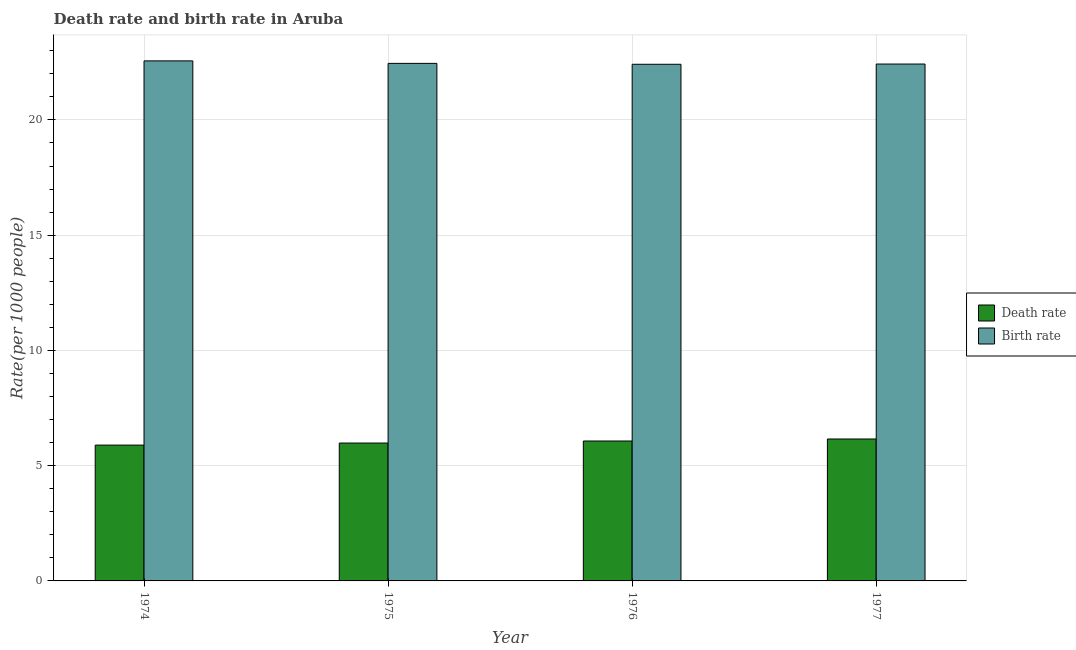How many groups of bars are there?
Your answer should be compact. 4. Are the number of bars on each tick of the X-axis equal?
Provide a succinct answer. Yes. What is the label of the 3rd group of bars from the left?
Make the answer very short. 1976. In how many cases, is the number of bars for a given year not equal to the number of legend labels?
Provide a succinct answer. 0. What is the birth rate in 1974?
Provide a short and direct response. 22.56. Across all years, what is the maximum death rate?
Your answer should be compact. 6.16. Across all years, what is the minimum death rate?
Your response must be concise. 5.89. In which year was the birth rate maximum?
Make the answer very short. 1974. In which year was the death rate minimum?
Make the answer very short. 1974. What is the total death rate in the graph?
Keep it short and to the point. 24.1. What is the difference between the birth rate in 1975 and that in 1976?
Provide a short and direct response. 0.04. What is the difference between the death rate in 1976 and the birth rate in 1975?
Your answer should be very brief. 0.09. What is the average death rate per year?
Provide a short and direct response. 6.03. In the year 1975, what is the difference between the death rate and birth rate?
Keep it short and to the point. 0. In how many years, is the birth rate greater than 7?
Provide a short and direct response. 4. What is the ratio of the birth rate in 1974 to that in 1976?
Make the answer very short. 1.01. What is the difference between the highest and the second highest birth rate?
Provide a succinct answer. 0.11. What is the difference between the highest and the lowest death rate?
Keep it short and to the point. 0.26. What does the 1st bar from the left in 1977 represents?
Give a very brief answer. Death rate. What does the 2nd bar from the right in 1975 represents?
Ensure brevity in your answer.  Death rate. How many bars are there?
Provide a short and direct response. 8. Are all the bars in the graph horizontal?
Give a very brief answer. No. What is the difference between two consecutive major ticks on the Y-axis?
Keep it short and to the point. 5. Are the values on the major ticks of Y-axis written in scientific E-notation?
Give a very brief answer. No. Does the graph contain any zero values?
Ensure brevity in your answer.  No. Does the graph contain grids?
Keep it short and to the point. Yes. Where does the legend appear in the graph?
Offer a very short reply. Center right. How are the legend labels stacked?
Provide a short and direct response. Vertical. What is the title of the graph?
Offer a terse response. Death rate and birth rate in Aruba. What is the label or title of the Y-axis?
Provide a succinct answer. Rate(per 1000 people). What is the Rate(per 1000 people) of Death rate in 1974?
Ensure brevity in your answer.  5.89. What is the Rate(per 1000 people) of Birth rate in 1974?
Provide a succinct answer. 22.56. What is the Rate(per 1000 people) in Death rate in 1975?
Provide a succinct answer. 5.98. What is the Rate(per 1000 people) in Birth rate in 1975?
Your answer should be compact. 22.45. What is the Rate(per 1000 people) of Death rate in 1976?
Ensure brevity in your answer.  6.07. What is the Rate(per 1000 people) of Birth rate in 1976?
Your response must be concise. 22.41. What is the Rate(per 1000 people) of Death rate in 1977?
Provide a short and direct response. 6.16. What is the Rate(per 1000 people) of Birth rate in 1977?
Your response must be concise. 22.42. Across all years, what is the maximum Rate(per 1000 people) of Death rate?
Your answer should be very brief. 6.16. Across all years, what is the maximum Rate(per 1000 people) in Birth rate?
Your response must be concise. 22.56. Across all years, what is the minimum Rate(per 1000 people) of Death rate?
Provide a succinct answer. 5.89. Across all years, what is the minimum Rate(per 1000 people) in Birth rate?
Ensure brevity in your answer.  22.41. What is the total Rate(per 1000 people) of Death rate in the graph?
Make the answer very short. 24.1. What is the total Rate(per 1000 people) of Birth rate in the graph?
Provide a short and direct response. 89.85. What is the difference between the Rate(per 1000 people) of Death rate in 1974 and that in 1975?
Your answer should be compact. -0.09. What is the difference between the Rate(per 1000 people) in Birth rate in 1974 and that in 1975?
Provide a short and direct response. 0.11. What is the difference between the Rate(per 1000 people) in Death rate in 1974 and that in 1976?
Offer a very short reply. -0.18. What is the difference between the Rate(per 1000 people) in Birth rate in 1974 and that in 1976?
Your answer should be compact. 0.15. What is the difference between the Rate(per 1000 people) of Death rate in 1974 and that in 1977?
Ensure brevity in your answer.  -0.27. What is the difference between the Rate(per 1000 people) in Birth rate in 1974 and that in 1977?
Offer a very short reply. 0.14. What is the difference between the Rate(per 1000 people) in Death rate in 1975 and that in 1976?
Make the answer very short. -0.09. What is the difference between the Rate(per 1000 people) in Birth rate in 1975 and that in 1976?
Your answer should be compact. 0.04. What is the difference between the Rate(per 1000 people) of Death rate in 1975 and that in 1977?
Ensure brevity in your answer.  -0.18. What is the difference between the Rate(per 1000 people) of Birth rate in 1975 and that in 1977?
Give a very brief answer. 0.03. What is the difference between the Rate(per 1000 people) of Death rate in 1976 and that in 1977?
Your answer should be compact. -0.09. What is the difference between the Rate(per 1000 people) in Birth rate in 1976 and that in 1977?
Give a very brief answer. -0.01. What is the difference between the Rate(per 1000 people) of Death rate in 1974 and the Rate(per 1000 people) of Birth rate in 1975?
Offer a terse response. -16.56. What is the difference between the Rate(per 1000 people) of Death rate in 1974 and the Rate(per 1000 people) of Birth rate in 1976?
Keep it short and to the point. -16.52. What is the difference between the Rate(per 1000 people) in Death rate in 1974 and the Rate(per 1000 people) in Birth rate in 1977?
Offer a terse response. -16.53. What is the difference between the Rate(per 1000 people) in Death rate in 1975 and the Rate(per 1000 people) in Birth rate in 1976?
Your response must be concise. -16.43. What is the difference between the Rate(per 1000 people) in Death rate in 1975 and the Rate(per 1000 people) in Birth rate in 1977?
Give a very brief answer. -16.44. What is the difference between the Rate(per 1000 people) in Death rate in 1976 and the Rate(per 1000 people) in Birth rate in 1977?
Provide a succinct answer. -16.35. What is the average Rate(per 1000 people) in Death rate per year?
Offer a terse response. 6.03. What is the average Rate(per 1000 people) in Birth rate per year?
Offer a terse response. 22.46. In the year 1974, what is the difference between the Rate(per 1000 people) of Death rate and Rate(per 1000 people) of Birth rate?
Give a very brief answer. -16.67. In the year 1975, what is the difference between the Rate(per 1000 people) of Death rate and Rate(per 1000 people) of Birth rate?
Provide a succinct answer. -16.47. In the year 1976, what is the difference between the Rate(per 1000 people) of Death rate and Rate(per 1000 people) of Birth rate?
Your answer should be very brief. -16.34. In the year 1977, what is the difference between the Rate(per 1000 people) in Death rate and Rate(per 1000 people) in Birth rate?
Provide a succinct answer. -16.27. What is the ratio of the Rate(per 1000 people) of Death rate in 1974 to that in 1975?
Offer a very short reply. 0.99. What is the ratio of the Rate(per 1000 people) in Birth rate in 1974 to that in 1975?
Your response must be concise. 1. What is the ratio of the Rate(per 1000 people) of Death rate in 1974 to that in 1976?
Offer a very short reply. 0.97. What is the ratio of the Rate(per 1000 people) of Birth rate in 1974 to that in 1976?
Your answer should be very brief. 1.01. What is the ratio of the Rate(per 1000 people) in Birth rate in 1974 to that in 1977?
Offer a terse response. 1.01. What is the ratio of the Rate(per 1000 people) of Death rate in 1975 to that in 1976?
Ensure brevity in your answer.  0.99. What is the ratio of the Rate(per 1000 people) of Birth rate in 1975 to that in 1976?
Your answer should be compact. 1. What is the ratio of the Rate(per 1000 people) in Death rate in 1975 to that in 1977?
Your answer should be compact. 0.97. What is the ratio of the Rate(per 1000 people) in Death rate in 1976 to that in 1977?
Provide a succinct answer. 0.99. What is the difference between the highest and the second highest Rate(per 1000 people) of Death rate?
Keep it short and to the point. 0.09. What is the difference between the highest and the second highest Rate(per 1000 people) of Birth rate?
Offer a terse response. 0.11. What is the difference between the highest and the lowest Rate(per 1000 people) in Death rate?
Make the answer very short. 0.27. What is the difference between the highest and the lowest Rate(per 1000 people) in Birth rate?
Give a very brief answer. 0.15. 